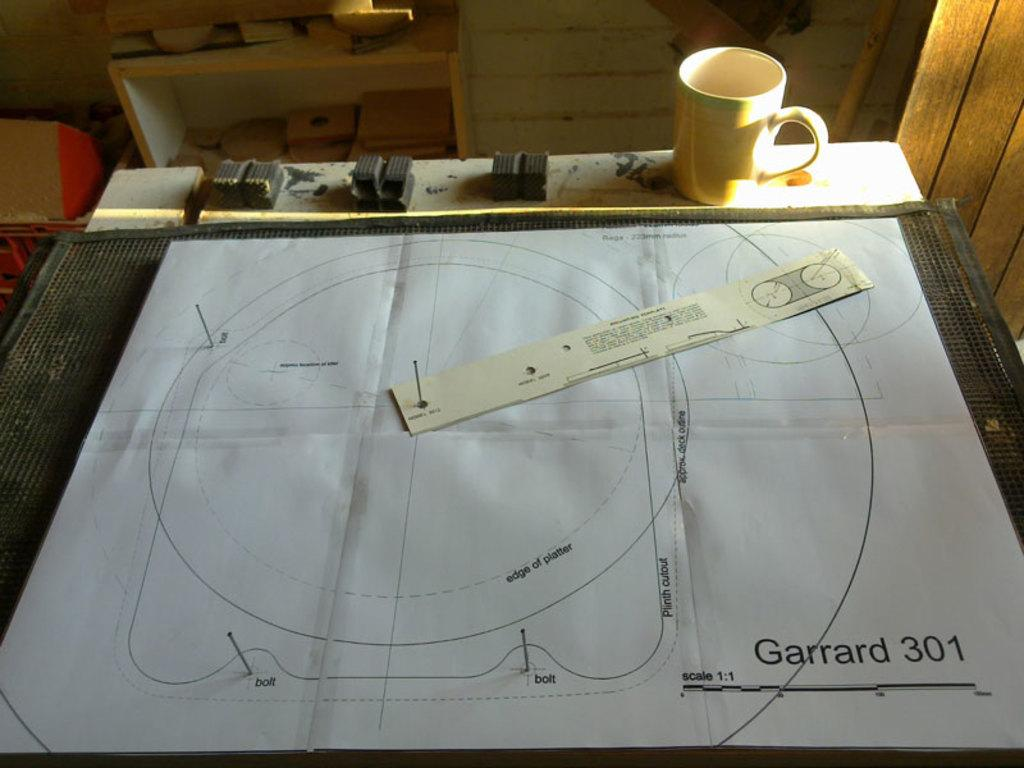<image>
Offer a succinct explanation of the picture presented. Some sort of plans that say Garrard 301 in the corner. 